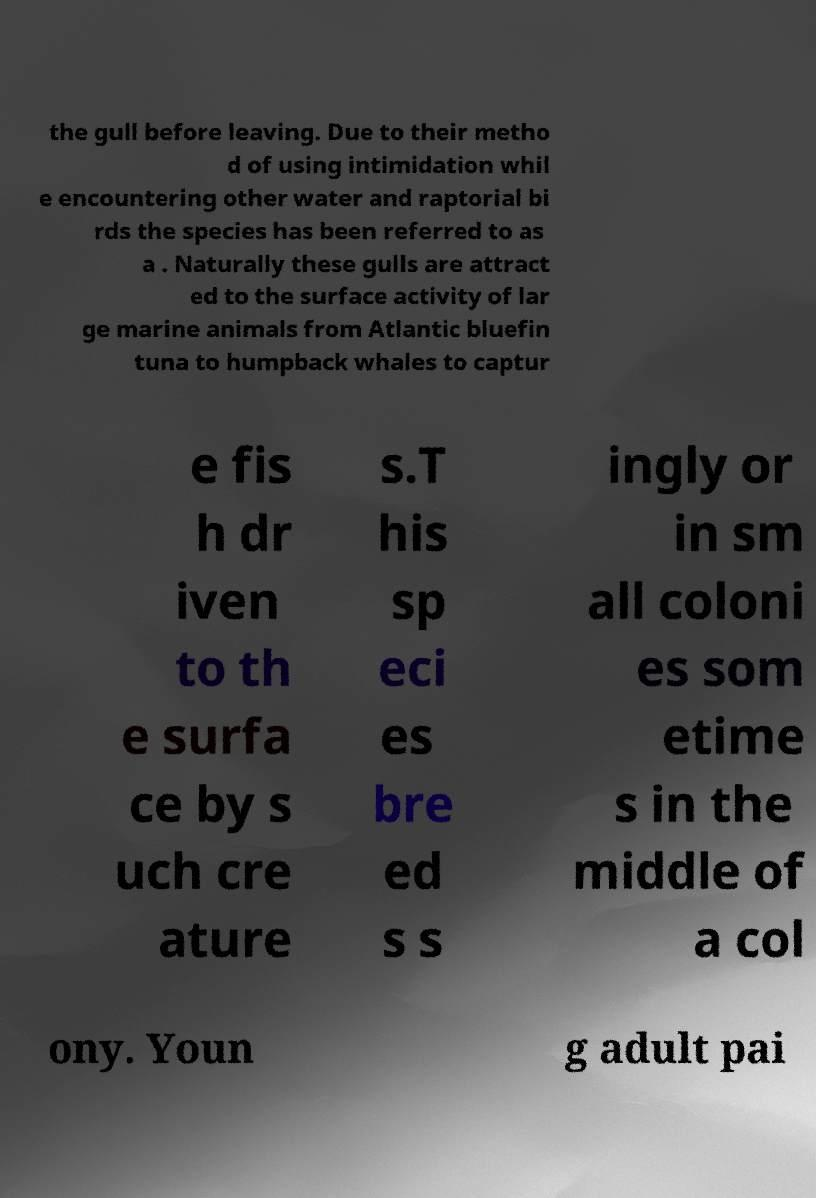For documentation purposes, I need the text within this image transcribed. Could you provide that? the gull before leaving. Due to their metho d of using intimidation whil e encountering other water and raptorial bi rds the species has been referred to as a . Naturally these gulls are attract ed to the surface activity of lar ge marine animals from Atlantic bluefin tuna to humpback whales to captur e fis h dr iven to th e surfa ce by s uch cre ature s.T his sp eci es bre ed s s ingly or in sm all coloni es som etime s in the middle of a col ony. Youn g adult pai 